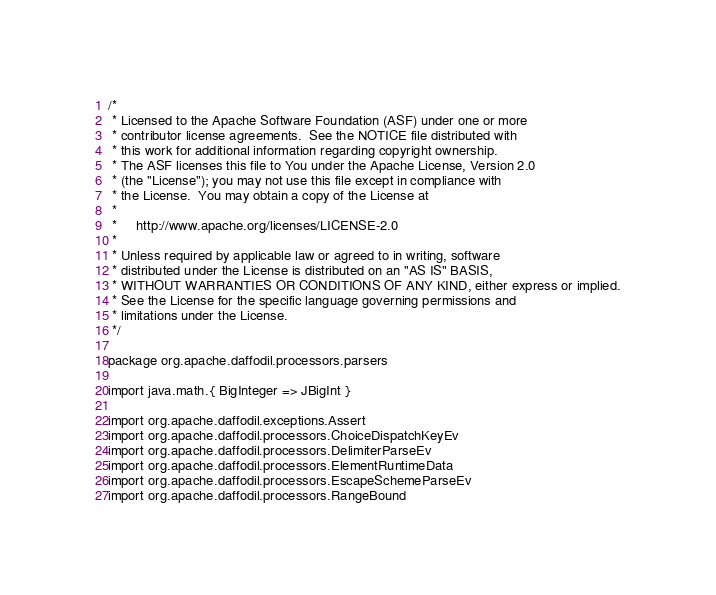Convert code to text. <code><loc_0><loc_0><loc_500><loc_500><_Scala_>/*
 * Licensed to the Apache Software Foundation (ASF) under one or more
 * contributor license agreements.  See the NOTICE file distributed with
 * this work for additional information regarding copyright ownership.
 * The ASF licenses this file to You under the Apache License, Version 2.0
 * (the "License"); you may not use this file except in compliance with
 * the License.  You may obtain a copy of the License at
 *
 *     http://www.apache.org/licenses/LICENSE-2.0
 *
 * Unless required by applicable law or agreed to in writing, software
 * distributed under the License is distributed on an "AS IS" BASIS,
 * WITHOUT WARRANTIES OR CONDITIONS OF ANY KIND, either express or implied.
 * See the License for the specific language governing permissions and
 * limitations under the License.
 */

package org.apache.daffodil.processors.parsers

import java.math.{ BigInteger => JBigInt }

import org.apache.daffodil.exceptions.Assert
import org.apache.daffodil.processors.ChoiceDispatchKeyEv
import org.apache.daffodil.processors.DelimiterParseEv
import org.apache.daffodil.processors.ElementRuntimeData
import org.apache.daffodil.processors.EscapeSchemeParseEv
import org.apache.daffodil.processors.RangeBound</code> 